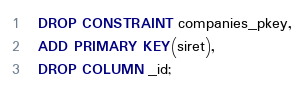Convert code to text. <code><loc_0><loc_0><loc_500><loc_500><_SQL_>  DROP CONSTRAINT companies_pkey,
  ADD PRIMARY KEY(siret),
  DROP COLUMN _id;
</code> 